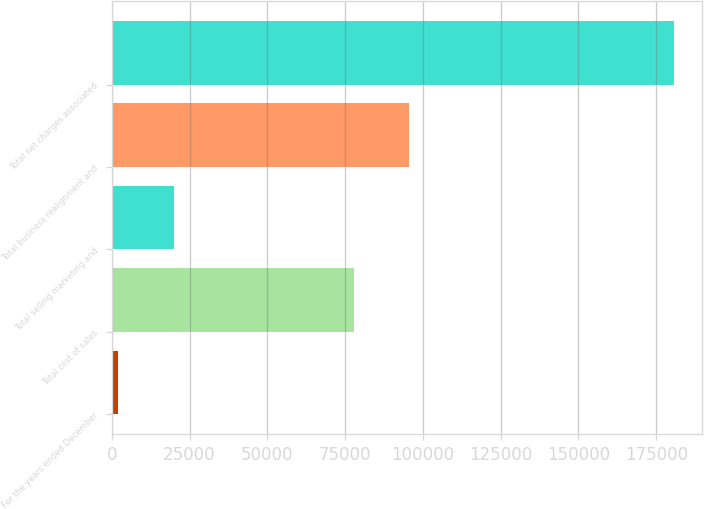Convert chart to OTSL. <chart><loc_0><loc_0><loc_500><loc_500><bar_chart><fcel>For the years ended December<fcel>Total cost of sales<fcel>Total selling marketing and<fcel>Total business realignment and<fcel>Total net charges associated<nl><fcel>2008<fcel>77767<fcel>19874.2<fcel>95633.2<fcel>180670<nl></chart> 